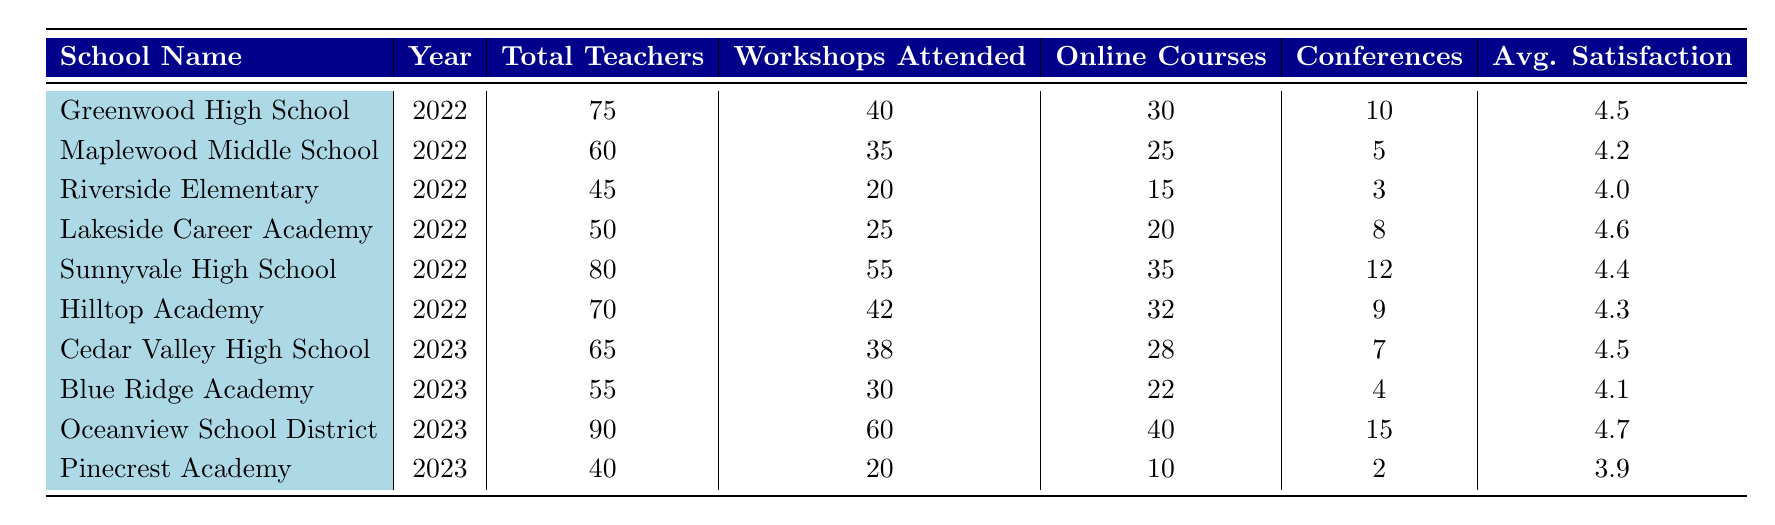What school had the highest average satisfaction rating in 2022? The average satisfaction ratings for 2022 are 4.5 for Greenwood High School, 4.2 for Maplewood Middle School, 4.0 for Riverside Elementary, 4.6 for Lakeside Career Academy, 4.4 for Sunnyvale High School, and 4.3 for Hilltop Academy. The highest rating is 4.6 for Lakeside Career Academy.
Answer: Lakeside Career Academy How many teachers attended workshops at Oceanview School District in 2023? According to the table, Oceanview School District had 60 workshops attended in 2023.
Answer: 60 What is the total number of conferences attended by all schools in 2022? The conferences attended in 2022 are: 10 for Greenwood, 5 for Maplewood, 3 for Riverside, 8 for Lakeside, 12 for Sunnyvale, and 9 for Hilltop. Summing these gives 10 + 5 + 3 + 8 + 12 + 9 = 47.
Answer: 47 Did Cedar Valley High School have more workshops attended than Blue Ridge Academy in 2023? Cedar Valley High School had 38 workshops attended while Blue Ridge Academy had 30 workshops attended. Therefore, Cedar Valley had more workshops attended.
Answer: Yes What is the difference in total teachers between Sunnyvale High School and Pinecrest Academy in 2023? Sunnyvale High School (2022) had 80 total teachers and Pinecrest Academy (2023) had 40 total teachers. The difference is 80 - 40 = 40 total teachers.
Answer: 40 Which school had the least number of online courses completed in 2022? The online courses completed in 2022 are: 30 for Greenwood, 25 for Maplewood, 15 for Riverside, 20 for Lakeside, 35 for Sunnyvale, and 32 for Hilltop. Riverside Elementary had the least with 15.
Answer: Riverside Elementary What was the average satisfaction rating for the schools in 2022? The average satisfaction ratings for 2022 are: 4.5, 4.2, 4.0, 4.6, 4.4, and 4.3. Adding these ratings gives 4.5 + 4.2 + 4.0 + 4.6 + 4.4 + 4.3 = 25. The average is then 25 / 6 = 4.17.
Answer: 4.17 Which school had the highest participation rate in workshops in 2022? The participation rates in workshops are calculated as follows: Greenwood 40/75, Maplewood 35/60, Riverside 20/45, Lakeside 25/50, Sunnyvale 55/80, and Hilltop 42/70. Converting these to percentages, we have 53.33%, 58.33%, 44.44%, 50%, 68.75%, and 60%. Sunnyvale High School has the highest participation rate at 68.75%.
Answer: Sunnyvale High School Based on the data, which year had the highest total number of teachers across all schools listed? Summing the total teachers for 2022 yields 75 + 60 + 45 + 50 + 80 + 70 = 380. For 2023, we sum 65 + 55 + 90 + 40 = 250. Since 380 > 250, 2022 had the highest total number of teachers.
Answer: 2022 